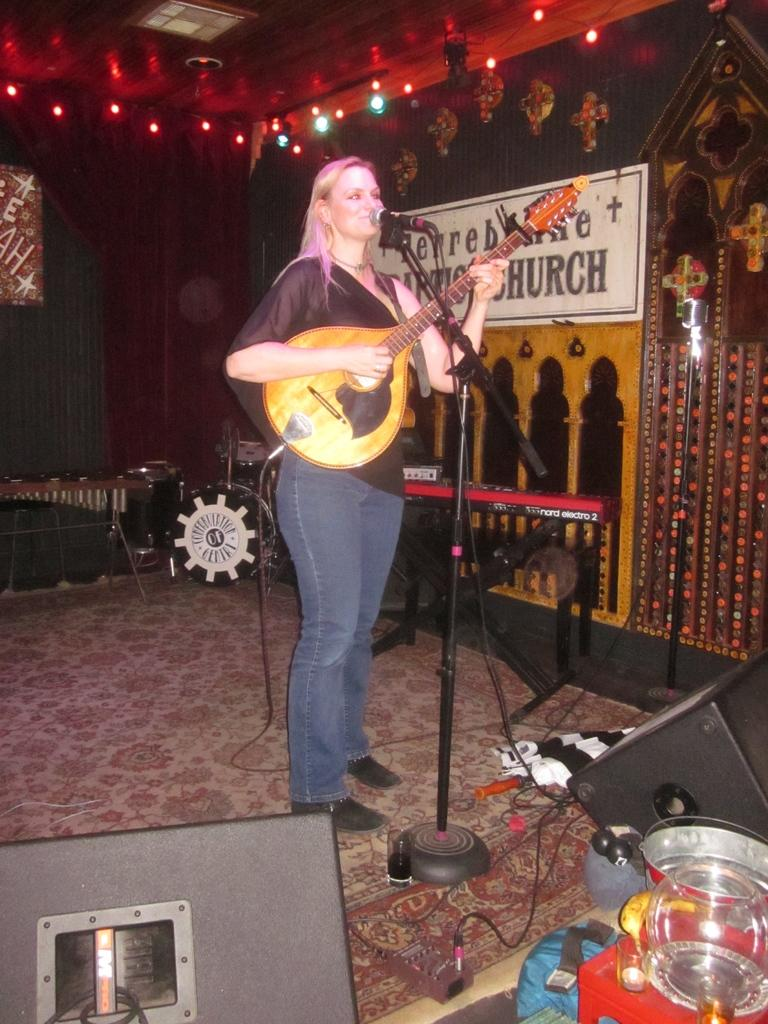Who is the main subject in the image? There is a woman in the image. What is the woman doing in the image? The woman is playing a guitar and standing on a stage. What is the woman positioned in front of? The woman is in front of a microphone. What can be seen in the background of the image? There are musical instruments and a wall in the background, along with some light. What type of popcorn is being served to the audience in the image? There is no popcorn present in the image; it is focused on a woman playing a guitar on a stage. What machine is responsible for creating the light in the background of the image? There is no machine visible in the image; there is just light in the background. 